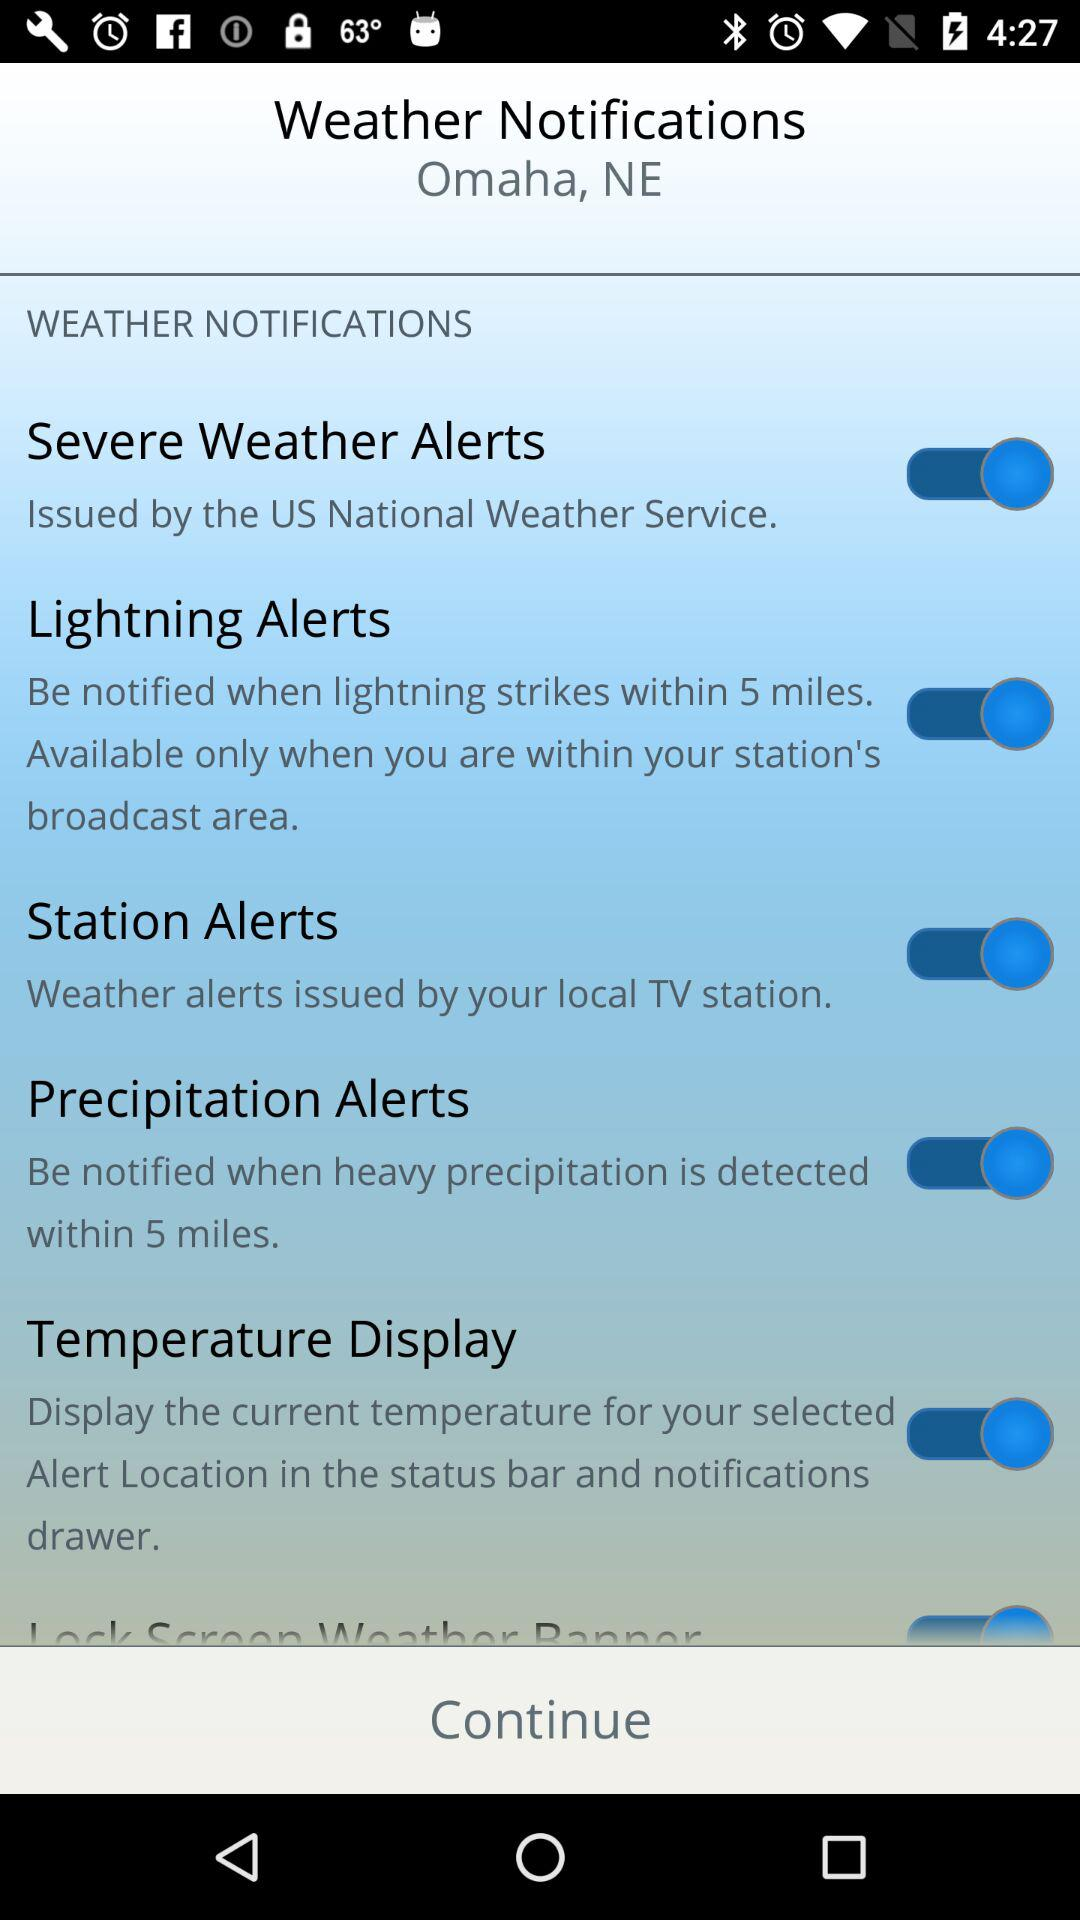What is the status of "Lightning Alerts"? The status is "on". 